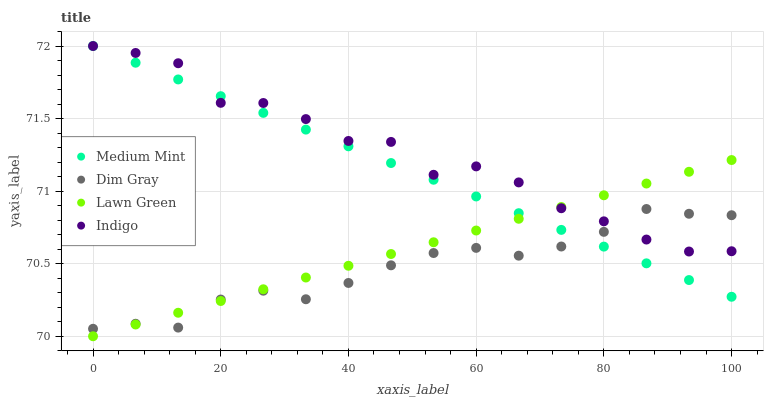Does Dim Gray have the minimum area under the curve?
Answer yes or no. Yes. Does Indigo have the maximum area under the curve?
Answer yes or no. Yes. Does Lawn Green have the minimum area under the curve?
Answer yes or no. No. Does Lawn Green have the maximum area under the curve?
Answer yes or no. No. Is Lawn Green the smoothest?
Answer yes or no. Yes. Is Indigo the roughest?
Answer yes or no. Yes. Is Dim Gray the smoothest?
Answer yes or no. No. Is Dim Gray the roughest?
Answer yes or no. No. Does Lawn Green have the lowest value?
Answer yes or no. Yes. Does Dim Gray have the lowest value?
Answer yes or no. No. Does Indigo have the highest value?
Answer yes or no. Yes. Does Lawn Green have the highest value?
Answer yes or no. No. Does Dim Gray intersect Indigo?
Answer yes or no. Yes. Is Dim Gray less than Indigo?
Answer yes or no. No. Is Dim Gray greater than Indigo?
Answer yes or no. No. 